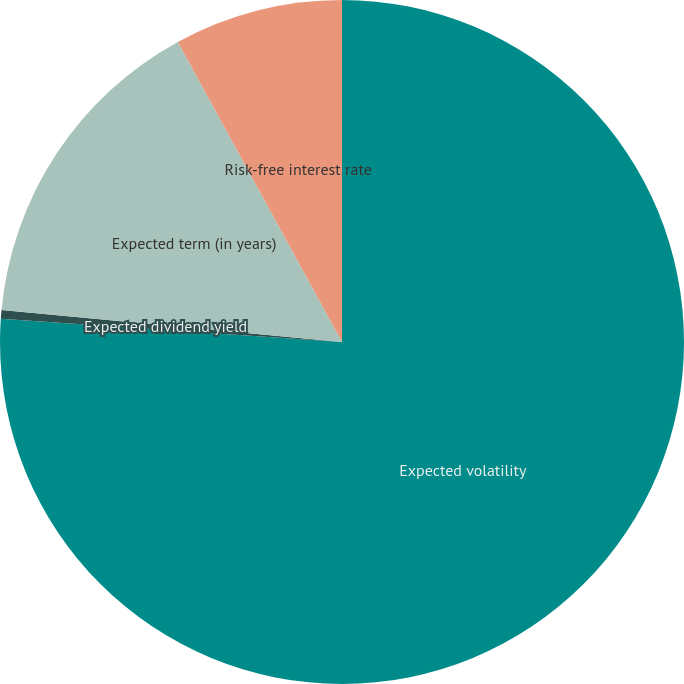Convert chart to OTSL. <chart><loc_0><loc_0><loc_500><loc_500><pie_chart><fcel>Expected volatility<fcel>Expected dividend yield<fcel>Expected term (in years)<fcel>Risk-free interest rate<nl><fcel>76.08%<fcel>0.41%<fcel>15.54%<fcel>7.97%<nl></chart> 